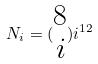<formula> <loc_0><loc_0><loc_500><loc_500>N _ { i } = ( \begin{matrix} 8 \\ i \end{matrix} ) i ^ { 1 2 }</formula> 